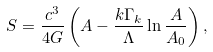Convert formula to latex. <formula><loc_0><loc_0><loc_500><loc_500>S = \frac { c ^ { 3 } } { 4 G } \left ( A - \frac { k \Gamma _ { k } } { \Lambda } \ln \frac { A } { A _ { 0 } } \right ) ,</formula> 